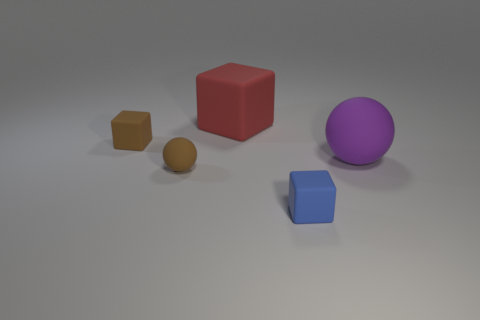Does the tiny sphere that is to the left of the big cube have the same color as the tiny block that is behind the small blue matte thing?
Offer a terse response. Yes. There is a rubber thing that is both left of the purple object and on the right side of the red block; what color is it?
Give a very brief answer. Blue. How many other objects are there of the same shape as the red matte thing?
Provide a short and direct response. 2. What is the color of the other matte cube that is the same size as the blue block?
Provide a short and direct response. Brown. What is the color of the tiny cube that is behind the small brown matte ball?
Provide a succinct answer. Brown. Are there any tiny blocks on the left side of the block in front of the brown cube?
Your response must be concise. Yes. There is a blue matte thing; does it have the same shape as the tiny brown matte object that is right of the brown rubber cube?
Give a very brief answer. No. What is the size of the matte cube that is both to the right of the small brown block and to the left of the tiny blue matte object?
Make the answer very short. Large. Are there any blue things that have the same material as the large red thing?
Your answer should be very brief. Yes. What size is the object that is the same color as the small rubber ball?
Your answer should be very brief. Small. 